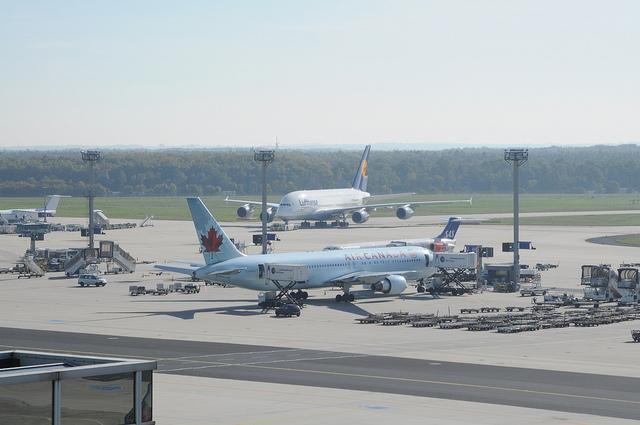Is this a quiet and serene location?
Answer briefly. No. Are there any people in the picture?
Short answer required. No. How many planes are there?
Short answer required. 3. How many planes on the runway?
Be succinct. 2. Is it raining?
Quick response, please. No. Is this a large airport?
Keep it brief. Yes. Would you want to have a life jacket if you were on this form of transportation?
Be succinct. No. What is on the poles?
Answer briefly. Lights. Is there another plane in the photo?
Quick response, please. Yes. How many planes are in the photo?
Quick response, please. 3. Is the plane flying?
Write a very short answer. No. What part of the world does this airplane come from?
Quick response, please. Canada. Is this a commercial airliner?
Short answer required. Yes. 